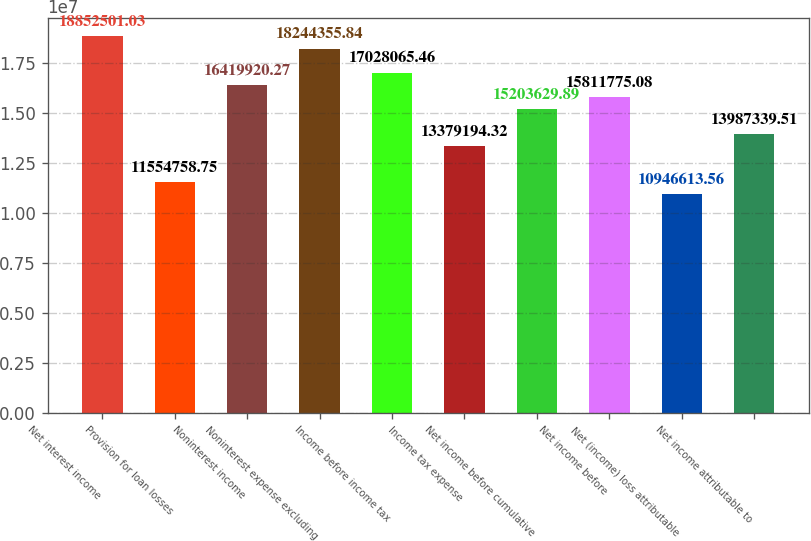Convert chart. <chart><loc_0><loc_0><loc_500><loc_500><bar_chart><fcel>Net interest income<fcel>Provision for loan losses<fcel>Noninterest income<fcel>Noninterest expense excluding<fcel>Income before income tax<fcel>Income tax expense<fcel>Net income before cumulative<fcel>Net income before<fcel>Net (income) loss attributable<fcel>Net income attributable to<nl><fcel>1.88525e+07<fcel>1.15548e+07<fcel>1.64199e+07<fcel>1.82444e+07<fcel>1.70281e+07<fcel>1.33792e+07<fcel>1.52036e+07<fcel>1.58118e+07<fcel>1.09466e+07<fcel>1.39873e+07<nl></chart> 